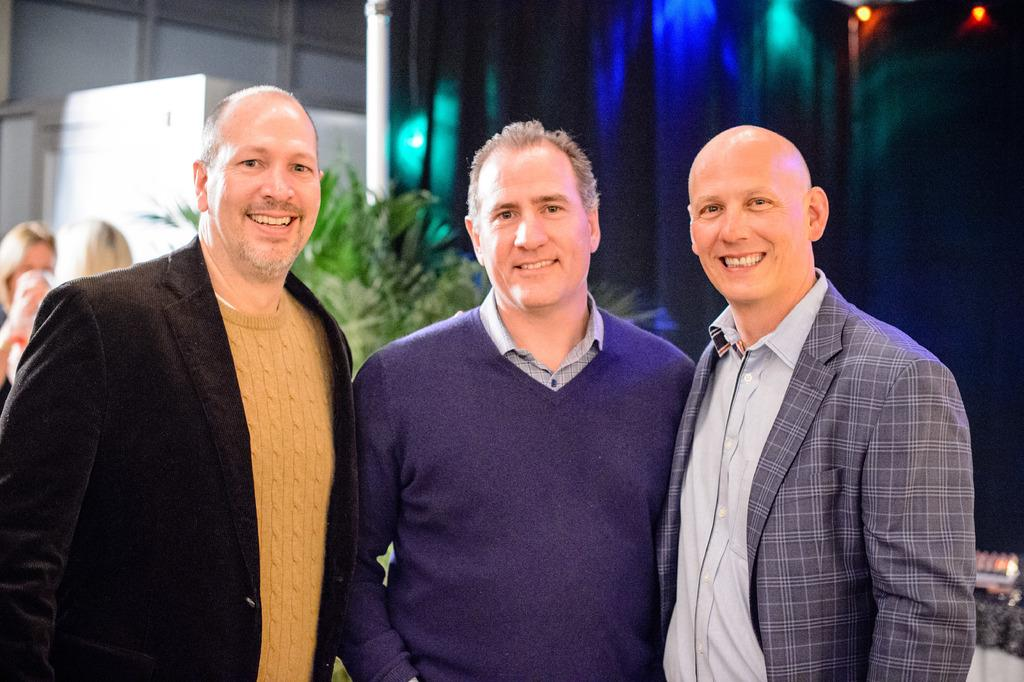Who or what is present in the image? There are people in the image. What can be seen in the background behind the people? There is a curtain with lights, poles, and plants in the background. Are there any objects in the top left corner of the image? Yes, there are objects in the top left corner of the image. What type of shock can be seen on the seat in the image? There is no seat or shock present in the image. How many balloons are visible in the image? There are no balloons visible in the image. 